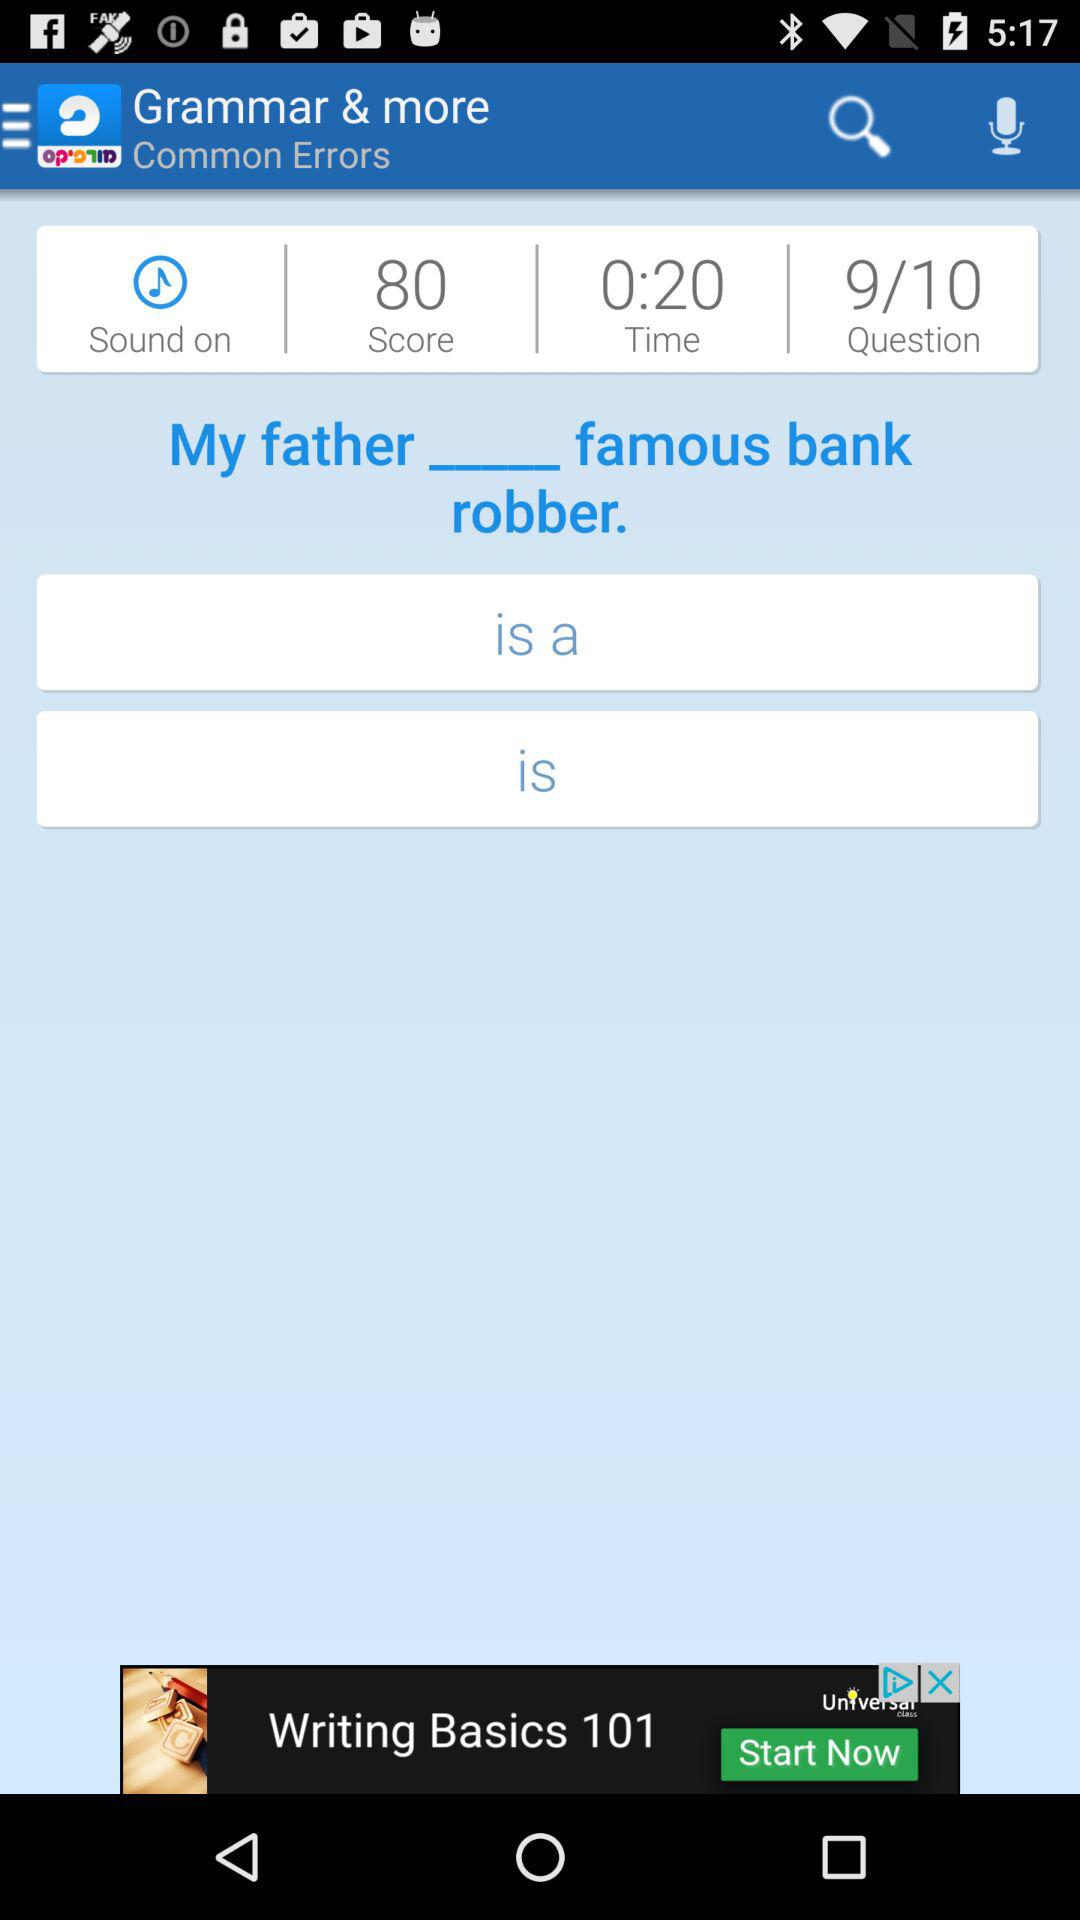Out of ten questions, how many are answered?
When the provided information is insufficient, respond with <no answer>. <no answer> 